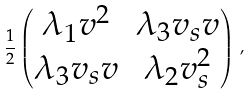<formula> <loc_0><loc_0><loc_500><loc_500>\frac { 1 } { 2 } \begin{pmatrix} \lambda _ { 1 } v ^ { 2 } & \lambda _ { 3 } v _ { s } v \\ \lambda _ { 3 } v _ { s } v & \lambda _ { 2 } v _ { s } ^ { 2 } \end{pmatrix} \, ,</formula> 